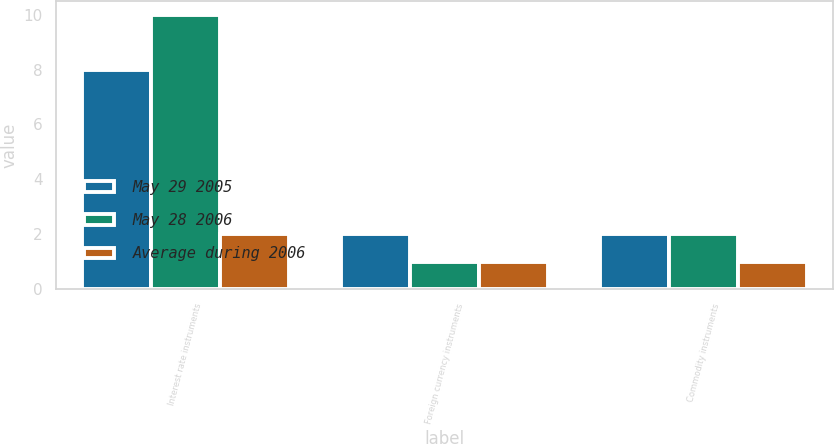<chart> <loc_0><loc_0><loc_500><loc_500><stacked_bar_chart><ecel><fcel>Interest rate instruments<fcel>Foreign currency instruments<fcel>Commodity instruments<nl><fcel>May 29 2005<fcel>8<fcel>2<fcel>2<nl><fcel>May 28 2006<fcel>10<fcel>1<fcel>2<nl><fcel>Average during 2006<fcel>2<fcel>1<fcel>1<nl></chart> 